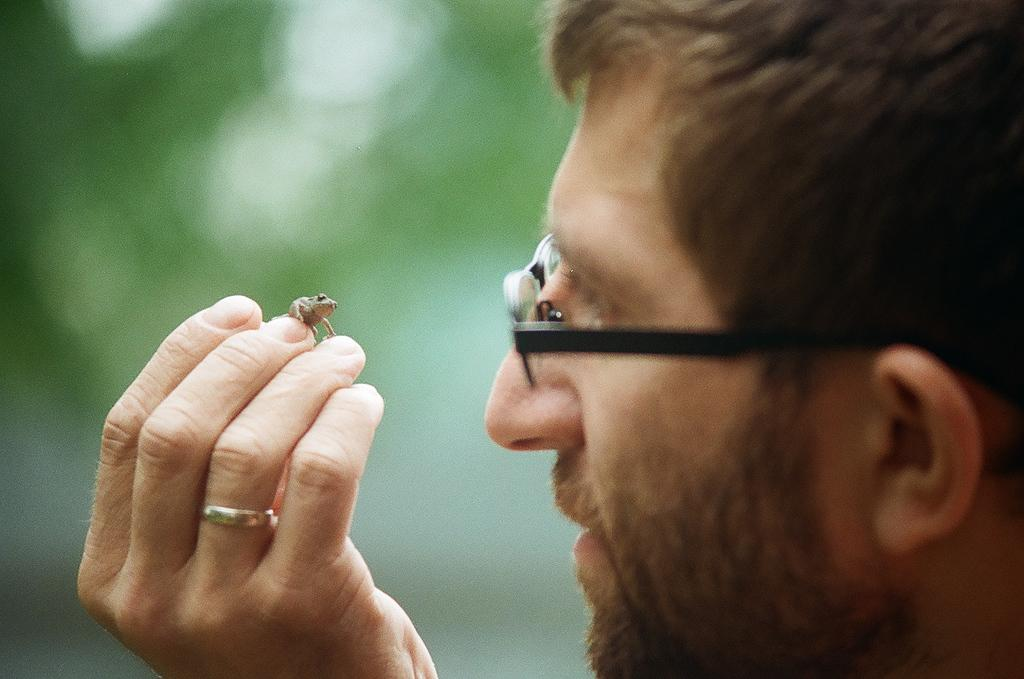Who is present in the image? There is a man in the image. What is the man holding in the image? The man is holding an animal. What accessory is the man wearing on his face? The man is wearing glasses. What piece of jewelry is the man wearing on his finger? The man is wearing a ring. What type of stew is the man eating with a fork in the image? There is no stew or fork present in the image; the man is holding an animal. 